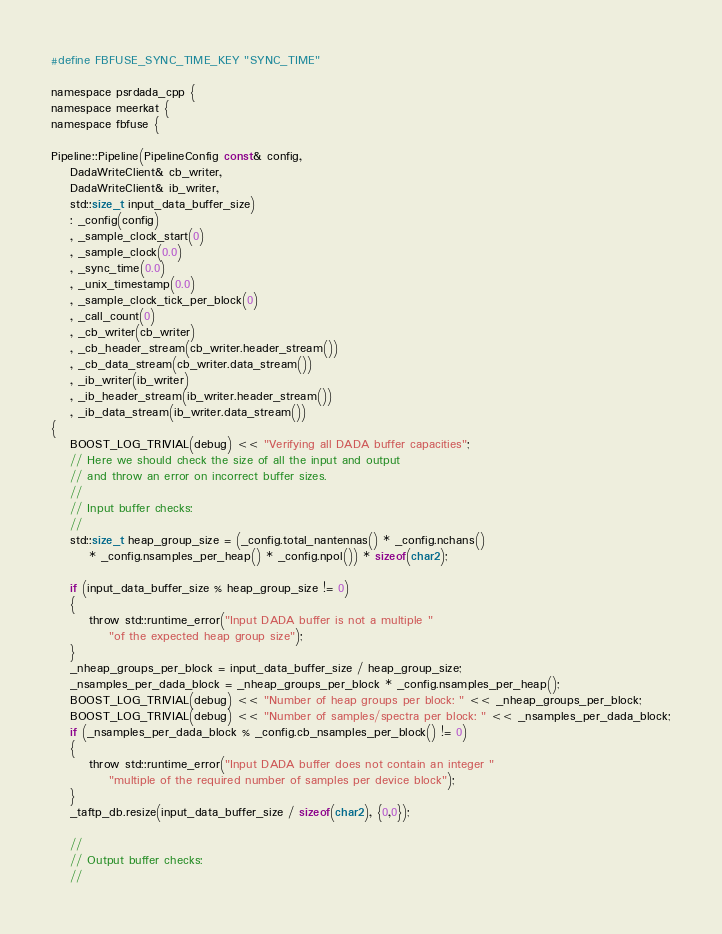Convert code to text. <code><loc_0><loc_0><loc_500><loc_500><_Cuda_>#define FBFUSE_SYNC_TIME_KEY "SYNC_TIME"

namespace psrdada_cpp {
namespace meerkat {
namespace fbfuse {

Pipeline::Pipeline(PipelineConfig const& config,
    DadaWriteClient& cb_writer,
    DadaWriteClient& ib_writer,
    std::size_t input_data_buffer_size)
    : _config(config)
    , _sample_clock_start(0)
    , _sample_clock(0.0)
    , _sync_time(0.0)
    , _unix_timestamp(0.0)
    , _sample_clock_tick_per_block(0)
    , _call_count(0)
    , _cb_writer(cb_writer)
    , _cb_header_stream(cb_writer.header_stream())
    , _cb_data_stream(cb_writer.data_stream())
    , _ib_writer(ib_writer)
    , _ib_header_stream(ib_writer.header_stream())
    , _ib_data_stream(ib_writer.data_stream())
{
    BOOST_LOG_TRIVIAL(debug) << "Verifying all DADA buffer capacities";
    // Here we should check the size of all the input and output
    // and throw an error on incorrect buffer sizes.
    //
    // Input buffer checks:
    //
    std::size_t heap_group_size = (_config.total_nantennas() * _config.nchans()
        * _config.nsamples_per_heap() * _config.npol()) * sizeof(char2);

    if (input_data_buffer_size % heap_group_size != 0)
    {
        throw std::runtime_error("Input DADA buffer is not a multiple "
            "of the expected heap group size");
    }
    _nheap_groups_per_block = input_data_buffer_size / heap_group_size;
    _nsamples_per_dada_block = _nheap_groups_per_block * _config.nsamples_per_heap();
    BOOST_LOG_TRIVIAL(debug) << "Number of heap groups per block: " << _nheap_groups_per_block;
    BOOST_LOG_TRIVIAL(debug) << "Number of samples/spectra per block: " << _nsamples_per_dada_block;
    if (_nsamples_per_dada_block % _config.cb_nsamples_per_block() != 0)
    {
        throw std::runtime_error("Input DADA buffer does not contain an integer "
            "multiple of the required number of samples per device block");
    }
    _taftp_db.resize(input_data_buffer_size / sizeof(char2), {0,0});

    //
    // Output buffer checks:
    //</code> 